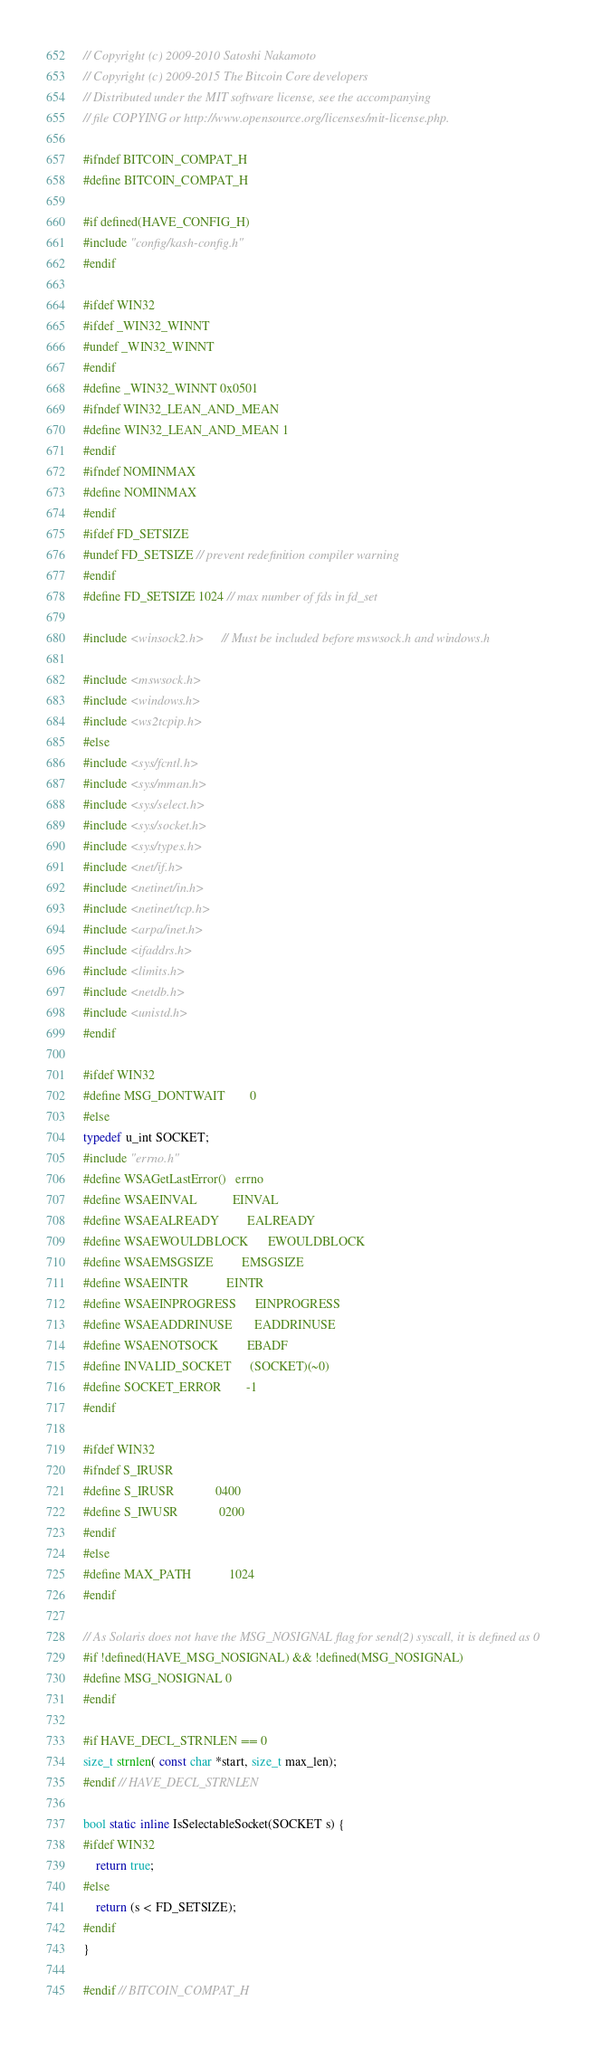<code> <loc_0><loc_0><loc_500><loc_500><_C_>// Copyright (c) 2009-2010 Satoshi Nakamoto
// Copyright (c) 2009-2015 The Bitcoin Core developers
// Distributed under the MIT software license, see the accompanying
// file COPYING or http://www.opensource.org/licenses/mit-license.php.

#ifndef BITCOIN_COMPAT_H
#define BITCOIN_COMPAT_H

#if defined(HAVE_CONFIG_H)
#include "config/kash-config.h"
#endif

#ifdef WIN32
#ifdef _WIN32_WINNT
#undef _WIN32_WINNT
#endif
#define _WIN32_WINNT 0x0501
#ifndef WIN32_LEAN_AND_MEAN
#define WIN32_LEAN_AND_MEAN 1
#endif
#ifndef NOMINMAX
#define NOMINMAX
#endif
#ifdef FD_SETSIZE
#undef FD_SETSIZE // prevent redefinition compiler warning
#endif
#define FD_SETSIZE 1024 // max number of fds in fd_set

#include <winsock2.h>     // Must be included before mswsock.h and windows.h

#include <mswsock.h>
#include <windows.h>
#include <ws2tcpip.h>
#else
#include <sys/fcntl.h>
#include <sys/mman.h>
#include <sys/select.h>
#include <sys/socket.h>
#include <sys/types.h>
#include <net/if.h>
#include <netinet/in.h>
#include <netinet/tcp.h>
#include <arpa/inet.h>
#include <ifaddrs.h>
#include <limits.h>
#include <netdb.h>
#include <unistd.h>
#endif

#ifdef WIN32
#define MSG_DONTWAIT        0
#else
typedef u_int SOCKET;
#include "errno.h"
#define WSAGetLastError()   errno
#define WSAEINVAL           EINVAL
#define WSAEALREADY         EALREADY
#define WSAEWOULDBLOCK      EWOULDBLOCK
#define WSAEMSGSIZE         EMSGSIZE
#define WSAEINTR            EINTR
#define WSAEINPROGRESS      EINPROGRESS
#define WSAEADDRINUSE       EADDRINUSE
#define WSAENOTSOCK         EBADF
#define INVALID_SOCKET      (SOCKET)(~0)
#define SOCKET_ERROR        -1
#endif

#ifdef WIN32
#ifndef S_IRUSR
#define S_IRUSR             0400
#define S_IWUSR             0200
#endif
#else
#define MAX_PATH            1024
#endif

// As Solaris does not have the MSG_NOSIGNAL flag for send(2) syscall, it is defined as 0
#if !defined(HAVE_MSG_NOSIGNAL) && !defined(MSG_NOSIGNAL)
#define MSG_NOSIGNAL 0
#endif

#if HAVE_DECL_STRNLEN == 0
size_t strnlen( const char *start, size_t max_len);
#endif // HAVE_DECL_STRNLEN

bool static inline IsSelectableSocket(SOCKET s) {
#ifdef WIN32
    return true;
#else
    return (s < FD_SETSIZE);
#endif
}

#endif // BITCOIN_COMPAT_H
</code> 